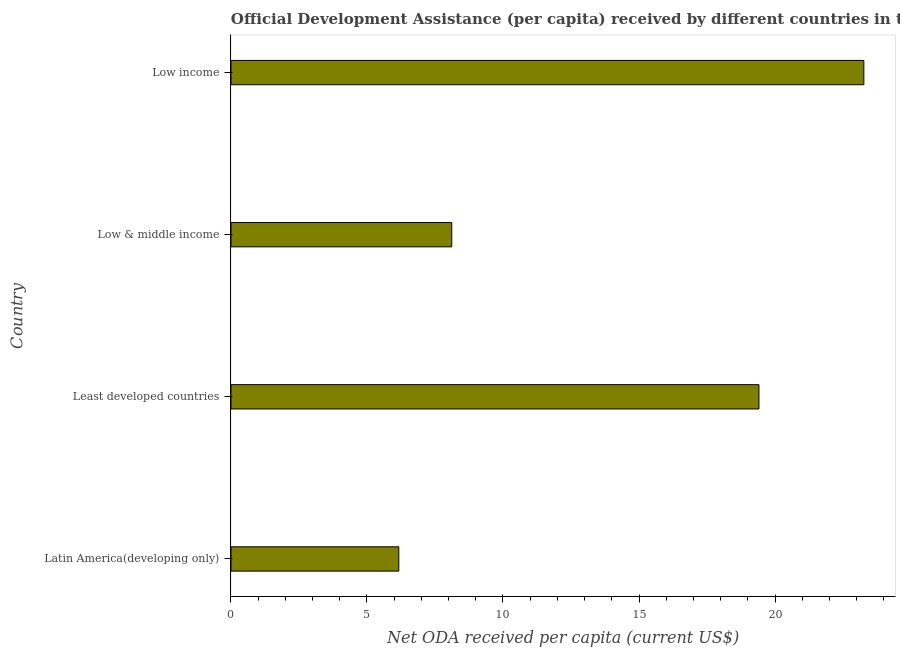Does the graph contain any zero values?
Your answer should be compact. No. Does the graph contain grids?
Your answer should be compact. No. What is the title of the graph?
Keep it short and to the point. Official Development Assistance (per capita) received by different countries in the year 1979. What is the label or title of the X-axis?
Keep it short and to the point. Net ODA received per capita (current US$). What is the label or title of the Y-axis?
Your response must be concise. Country. What is the net oda received per capita in Low income?
Provide a succinct answer. 23.27. Across all countries, what is the maximum net oda received per capita?
Provide a succinct answer. 23.27. Across all countries, what is the minimum net oda received per capita?
Your answer should be compact. 6.17. In which country was the net oda received per capita maximum?
Ensure brevity in your answer.  Low income. In which country was the net oda received per capita minimum?
Provide a succinct answer. Latin America(developing only). What is the sum of the net oda received per capita?
Give a very brief answer. 56.96. What is the difference between the net oda received per capita in Low & middle income and Low income?
Give a very brief answer. -15.15. What is the average net oda received per capita per country?
Provide a short and direct response. 14.24. What is the median net oda received per capita?
Provide a succinct answer. 13.76. In how many countries, is the net oda received per capita greater than 8 US$?
Make the answer very short. 3. What is the ratio of the net oda received per capita in Low & middle income to that in Low income?
Provide a short and direct response. 0.35. Is the difference between the net oda received per capita in Latin America(developing only) and Low income greater than the difference between any two countries?
Keep it short and to the point. Yes. What is the difference between the highest and the second highest net oda received per capita?
Give a very brief answer. 3.86. In how many countries, is the net oda received per capita greater than the average net oda received per capita taken over all countries?
Keep it short and to the point. 2. Are all the bars in the graph horizontal?
Your response must be concise. Yes. How many countries are there in the graph?
Offer a terse response. 4. What is the difference between two consecutive major ticks on the X-axis?
Your answer should be compact. 5. What is the Net ODA received per capita (current US$) of Latin America(developing only)?
Make the answer very short. 6.17. What is the Net ODA received per capita (current US$) of Least developed countries?
Ensure brevity in your answer.  19.41. What is the Net ODA received per capita (current US$) in Low & middle income?
Make the answer very short. 8.12. What is the Net ODA received per capita (current US$) in Low income?
Your answer should be compact. 23.27. What is the difference between the Net ODA received per capita (current US$) in Latin America(developing only) and Least developed countries?
Keep it short and to the point. -13.24. What is the difference between the Net ODA received per capita (current US$) in Latin America(developing only) and Low & middle income?
Keep it short and to the point. -1.95. What is the difference between the Net ODA received per capita (current US$) in Latin America(developing only) and Low income?
Offer a terse response. -17.1. What is the difference between the Net ODA received per capita (current US$) in Least developed countries and Low & middle income?
Make the answer very short. 11.29. What is the difference between the Net ODA received per capita (current US$) in Least developed countries and Low income?
Your response must be concise. -3.86. What is the difference between the Net ODA received per capita (current US$) in Low & middle income and Low income?
Make the answer very short. -15.15. What is the ratio of the Net ODA received per capita (current US$) in Latin America(developing only) to that in Least developed countries?
Keep it short and to the point. 0.32. What is the ratio of the Net ODA received per capita (current US$) in Latin America(developing only) to that in Low & middle income?
Make the answer very short. 0.76. What is the ratio of the Net ODA received per capita (current US$) in Latin America(developing only) to that in Low income?
Provide a succinct answer. 0.27. What is the ratio of the Net ODA received per capita (current US$) in Least developed countries to that in Low & middle income?
Your answer should be very brief. 2.39. What is the ratio of the Net ODA received per capita (current US$) in Least developed countries to that in Low income?
Make the answer very short. 0.83. What is the ratio of the Net ODA received per capita (current US$) in Low & middle income to that in Low income?
Your response must be concise. 0.35. 